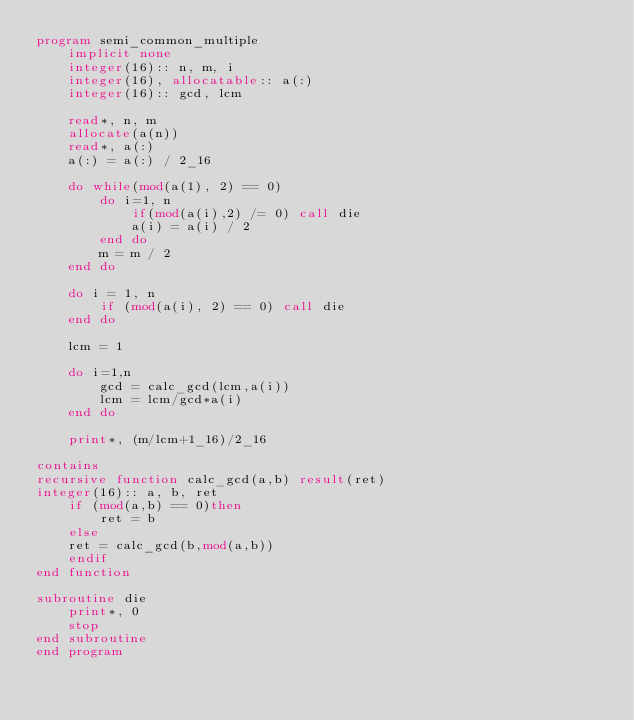Convert code to text. <code><loc_0><loc_0><loc_500><loc_500><_FORTRAN_>program semi_common_multiple
    implicit none
    integer(16):: n, m, i
    integer(16), allocatable:: a(:)
    integer(16):: gcd, lcm

    read*, n, m
    allocate(a(n))
    read*, a(:)
    a(:) = a(:) / 2_16

    do while(mod(a(1), 2) == 0)
        do i=1, n
            if(mod(a(i),2) /= 0) call die
            a(i) = a(i) / 2
        end do
        m = m / 2
    end do

    do i = 1, n
        if (mod(a(i), 2) == 0) call die
    end do

    lcm = 1

    do i=1,n
        gcd = calc_gcd(lcm,a(i))
        lcm = lcm/gcd*a(i)
    end do

    print*, (m/lcm+1_16)/2_16

contains
recursive function calc_gcd(a,b) result(ret)
integer(16):: a, b, ret
    if (mod(a,b) == 0)then
        ret = b
    else
    ret = calc_gcd(b,mod(a,b))
    endif
end function

subroutine die
    print*, 0
    stop
end subroutine
end program</code> 